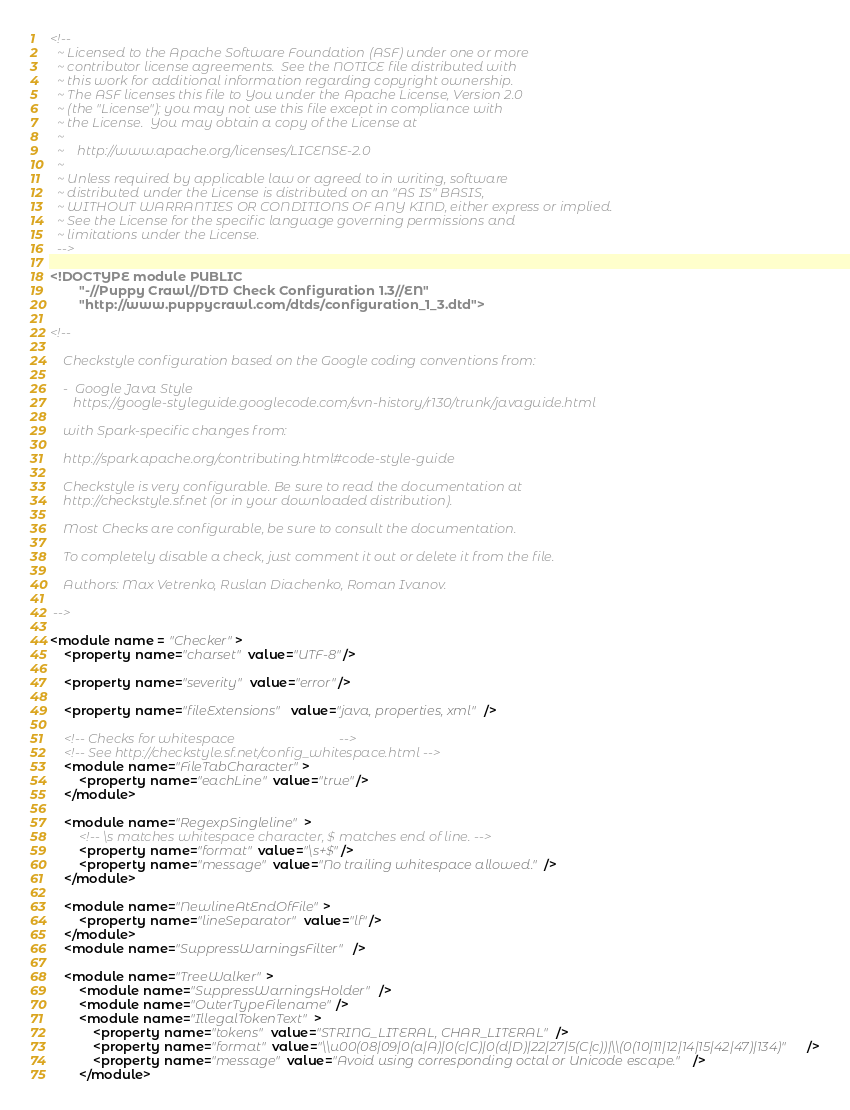<code> <loc_0><loc_0><loc_500><loc_500><_XML_><!--
  ~ Licensed to the Apache Software Foundation (ASF) under one or more
  ~ contributor license agreements.  See the NOTICE file distributed with
  ~ this work for additional information regarding copyright ownership.
  ~ The ASF licenses this file to You under the Apache License, Version 2.0
  ~ (the "License"); you may not use this file except in compliance with
  ~ the License.  You may obtain a copy of the License at
  ~
  ~    http://www.apache.org/licenses/LICENSE-2.0
  ~
  ~ Unless required by applicable law or agreed to in writing, software
  ~ distributed under the License is distributed on an "AS IS" BASIS,
  ~ WITHOUT WARRANTIES OR CONDITIONS OF ANY KIND, either express or implied.
  ~ See the License for the specific language governing permissions and
  ~ limitations under the License.
  -->

<!DOCTYPE module PUBLIC
        "-//Puppy Crawl//DTD Check Configuration 1.3//EN"
        "http://www.puppycrawl.com/dtds/configuration_1_3.dtd">

<!--

    Checkstyle configuration based on the Google coding conventions from:

    -  Google Java Style
       https://google-styleguide.googlecode.com/svn-history/r130/trunk/javaguide.html

    with Spark-specific changes from:

    http://spark.apache.org/contributing.html#code-style-guide

    Checkstyle is very configurable. Be sure to read the documentation at
    http://checkstyle.sf.net (or in your downloaded distribution).

    Most Checks are configurable, be sure to consult the documentation.

    To completely disable a check, just comment it out or delete it from the file.

    Authors: Max Vetrenko, Ruslan Diachenko, Roman Ivanov.

 -->

<module name = "Checker">
    <property name="charset" value="UTF-8"/>

    <property name="severity" value="error"/>

    <property name="fileExtensions" value="java, properties, xml"/>

    <!-- Checks for whitespace                               -->
    <!-- See http://checkstyle.sf.net/config_whitespace.html -->
    <module name="FileTabCharacter">
        <property name="eachLine" value="true"/>
    </module>

    <module name="RegexpSingleline">
        <!-- \s matches whitespace character, $ matches end of line. -->
        <property name="format" value="\s+$"/>
        <property name="message" value="No trailing whitespace allowed."/>
    </module>

    <module name="NewlineAtEndOfFile">
        <property name="lineSeparator" value="lf"/>
    </module>
    <module name="SuppressWarningsFilter" />

    <module name="TreeWalker">
        <module name="SuppressWarningsHolder" />
        <module name="OuterTypeFilename"/>
        <module name="IllegalTokenText">
            <property name="tokens" value="STRING_LITERAL, CHAR_LITERAL"/>
            <property name="format" value="\\u00(08|09|0(a|A)|0(c|C)|0(d|D)|22|27|5(C|c))|\\(0(10|11|12|14|15|42|47)|134)"/>
            <property name="message" value="Avoid using corresponding octal or Unicode escape."/>
        </module></code> 